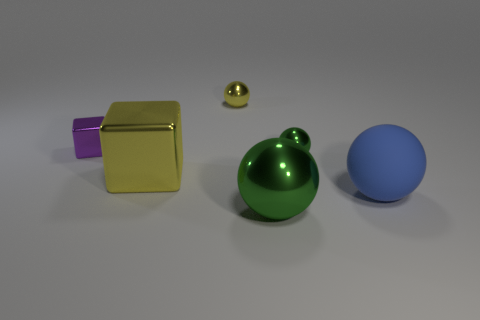What number of things are tiny purple shiny cubes or big metal objects to the right of the large shiny cube?
Provide a short and direct response. 2. Is the matte object the same size as the yellow metallic cube?
Provide a short and direct response. Yes. There is a large yellow metal object; are there any purple metal blocks in front of it?
Your answer should be very brief. No. What size is the ball that is in front of the yellow block and left of the blue thing?
Your answer should be compact. Large. How many objects are metallic cylinders or big green things?
Provide a succinct answer. 1. Does the matte object have the same size as the green shiny object that is behind the big blue object?
Ensure brevity in your answer.  No. There is a shiny sphere in front of the green shiny ball behind the yellow shiny thing in front of the purple metal cube; what size is it?
Your response must be concise. Large. Is there a blue rubber ball?
Provide a succinct answer. Yes. What is the material of the object that is the same color as the big block?
Provide a short and direct response. Metal. How many large metallic things have the same color as the tiny cube?
Make the answer very short. 0. 